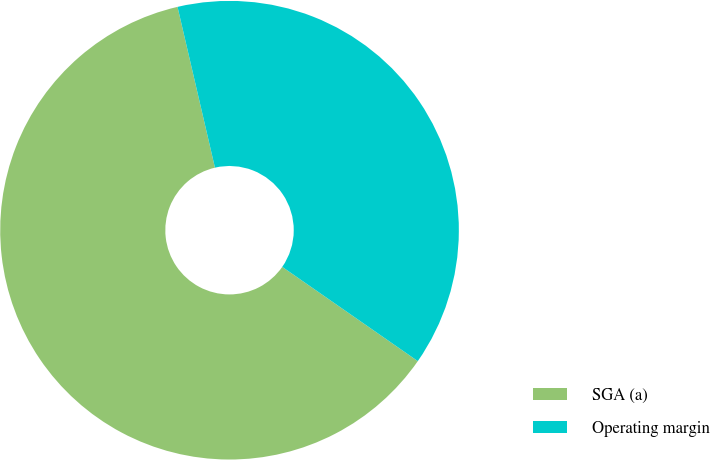<chart> <loc_0><loc_0><loc_500><loc_500><pie_chart><fcel>SGA (a)<fcel>Operating margin<nl><fcel>61.69%<fcel>38.31%<nl></chart> 